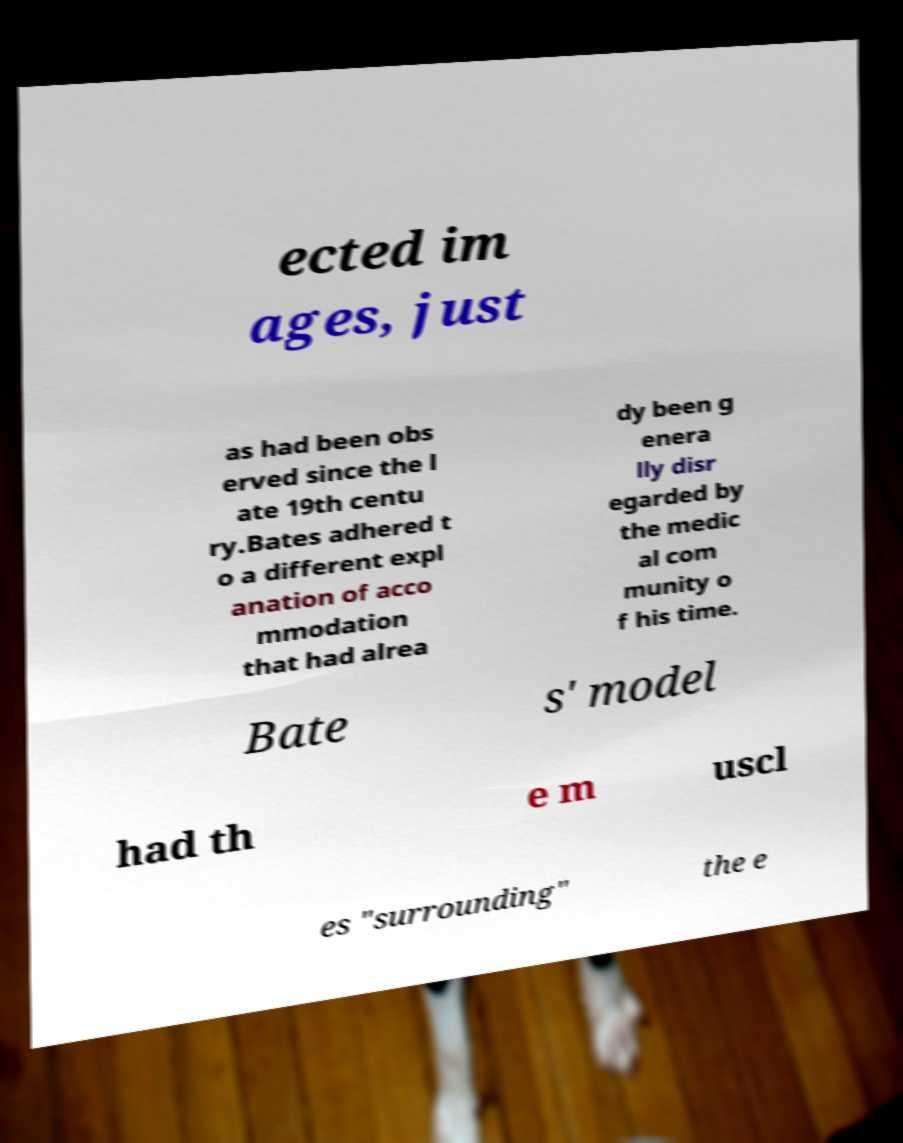There's text embedded in this image that I need extracted. Can you transcribe it verbatim? ected im ages, just as had been obs erved since the l ate 19th centu ry.Bates adhered t o a different expl anation of acco mmodation that had alrea dy been g enera lly disr egarded by the medic al com munity o f his time. Bate s' model had th e m uscl es "surrounding" the e 